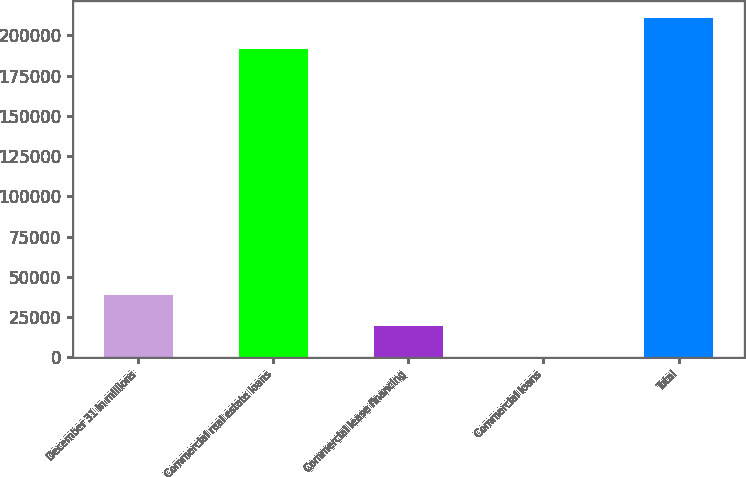Convert chart to OTSL. <chart><loc_0><loc_0><loc_500><loc_500><bar_chart><fcel>December 31 in millions<fcel>Commercial real estate loans<fcel>Commercial lease financing<fcel>Commercial loans<fcel>Total<nl><fcel>39087.6<fcel>191407<fcel>19715.8<fcel>344<fcel>210779<nl></chart> 